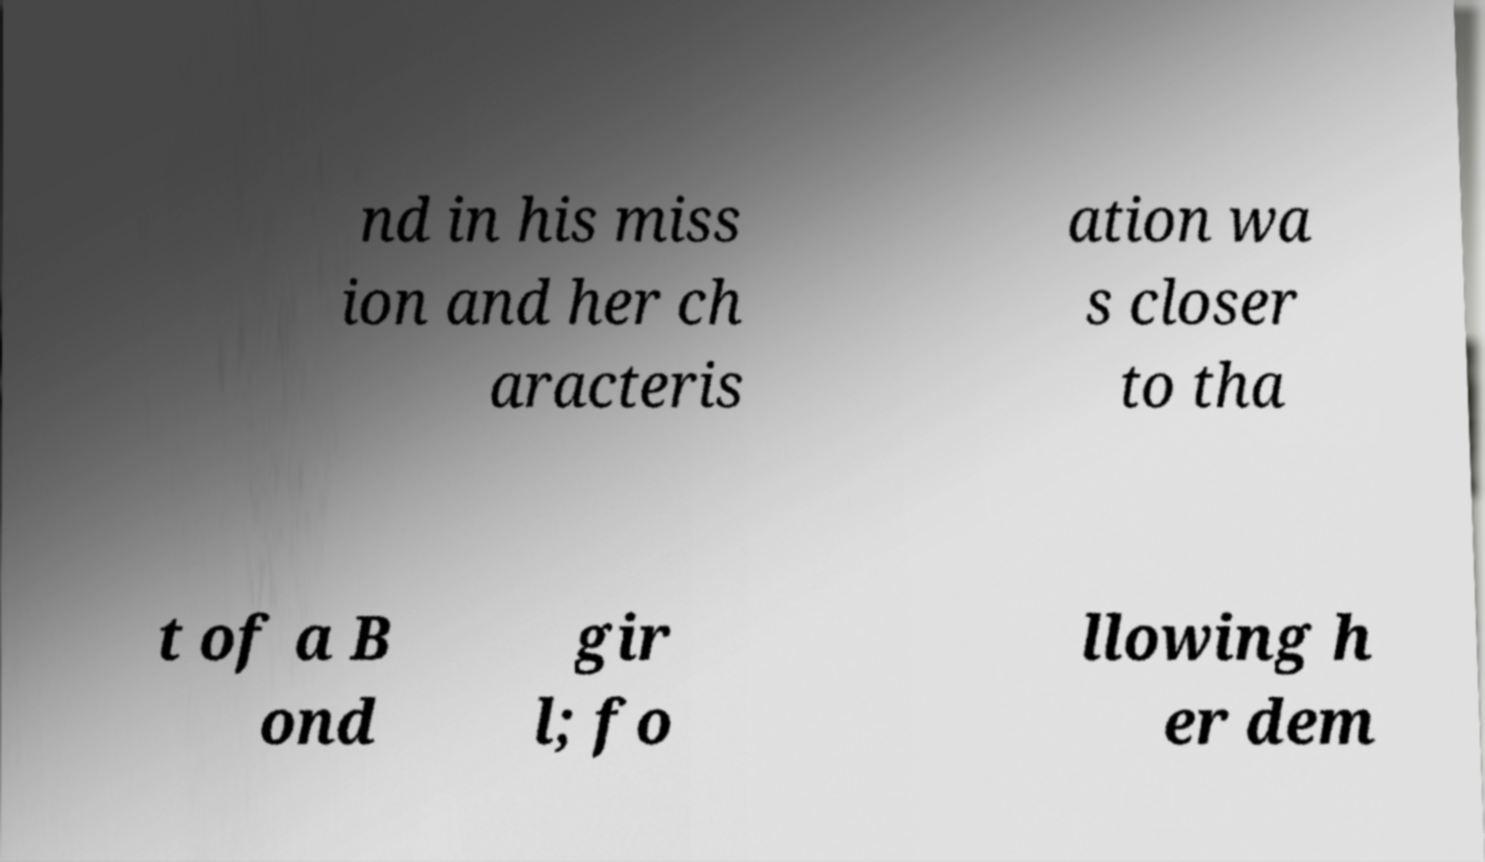Can you read and provide the text displayed in the image?This photo seems to have some interesting text. Can you extract and type it out for me? nd in his miss ion and her ch aracteris ation wa s closer to tha t of a B ond gir l; fo llowing h er dem 